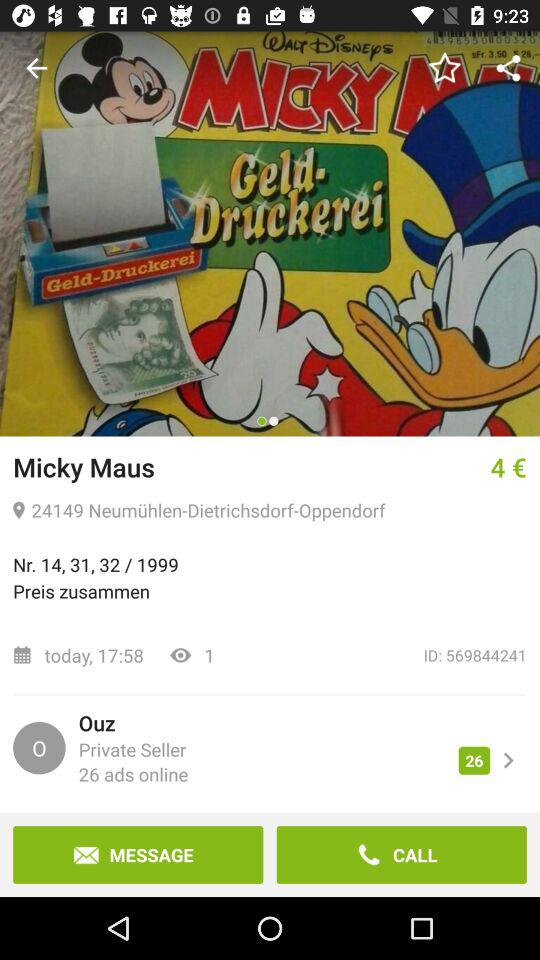How much is the price of the item?
Answer the question using a single word or phrase. 4 € 